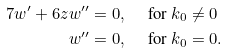<formula> <loc_0><loc_0><loc_500><loc_500>7 w ^ { \prime } + 6 z w ^ { \prime \prime } & = 0 , \quad \text { for $k_{0} \neq 0$} \\ w ^ { \prime \prime } & = 0 , \quad \text { for $k_{0}=0.$}</formula> 